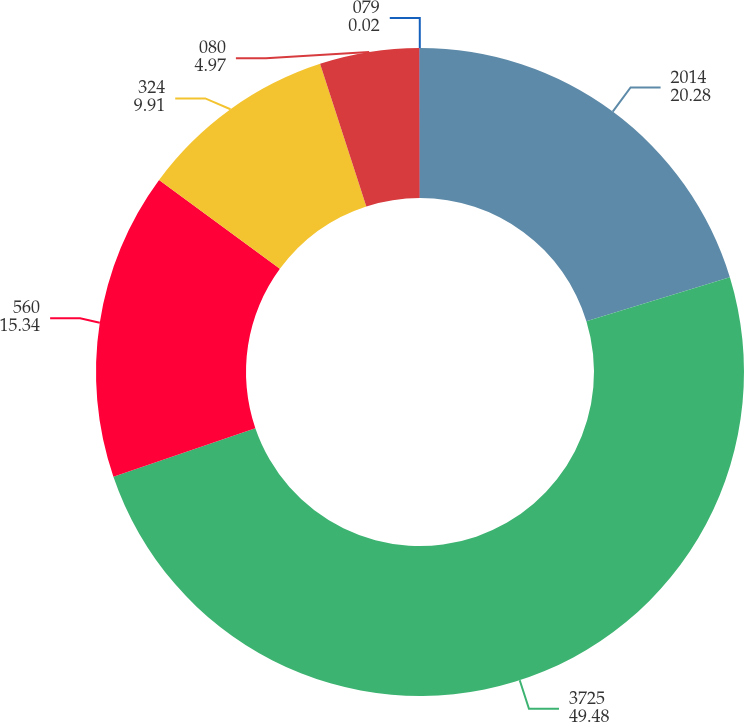<chart> <loc_0><loc_0><loc_500><loc_500><pie_chart><fcel>2014<fcel>3725<fcel>560<fcel>324<fcel>080<fcel>079<nl><fcel>20.28%<fcel>49.48%<fcel>15.34%<fcel>9.91%<fcel>4.97%<fcel>0.02%<nl></chart> 